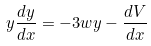Convert formula to latex. <formula><loc_0><loc_0><loc_500><loc_500>y \frac { d y } { d x } = - 3 w y - \frac { d V } { d x }</formula> 